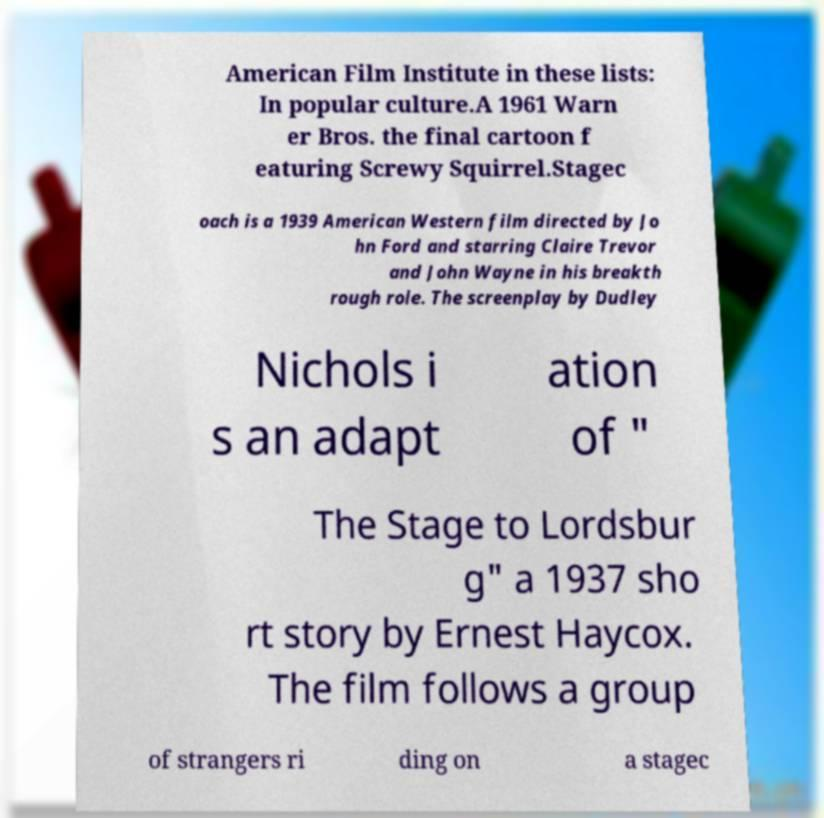Could you extract and type out the text from this image? American Film Institute in these lists: In popular culture.A 1961 Warn er Bros. the final cartoon f eaturing Screwy Squirrel.Stagec oach is a 1939 American Western film directed by Jo hn Ford and starring Claire Trevor and John Wayne in his breakth rough role. The screenplay by Dudley Nichols i s an adapt ation of " The Stage to Lordsbur g" a 1937 sho rt story by Ernest Haycox. The film follows a group of strangers ri ding on a stagec 